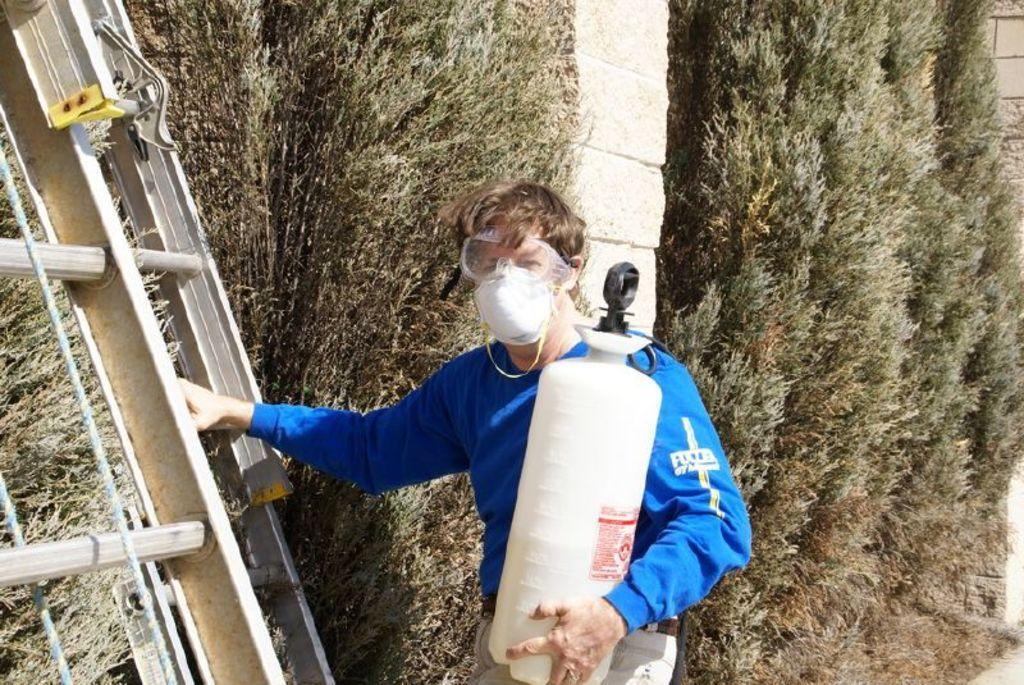Could you give a brief overview of what you see in this image? Here I can see a man wearing blue color t-shirt, holding a white color bottle in the hand. On the left side, I can see a ladder which is made up of metal. In the background, I can see some trees and a wall. 